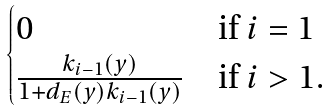Convert formula to latex. <formula><loc_0><loc_0><loc_500><loc_500>\begin{cases} 0 & \text {if $i=1$} \\ \frac { k _ { i - 1 } ( y ) } { 1 + d _ { E } ( y ) k _ { i - 1 } ( y ) } & \text {if $i>1.$} \end{cases}</formula> 